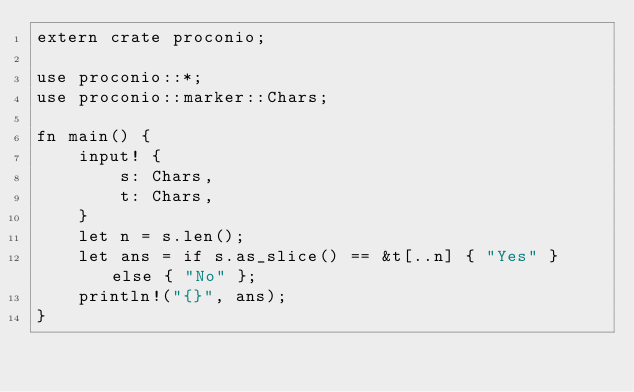<code> <loc_0><loc_0><loc_500><loc_500><_Rust_>extern crate proconio;

use proconio::*;
use proconio::marker::Chars;

fn main() {
    input! {
        s: Chars,
        t: Chars,
    }
    let n = s.len();
    let ans = if s.as_slice() == &t[..n] { "Yes" } else { "No" };
    println!("{}", ans);
}
</code> 